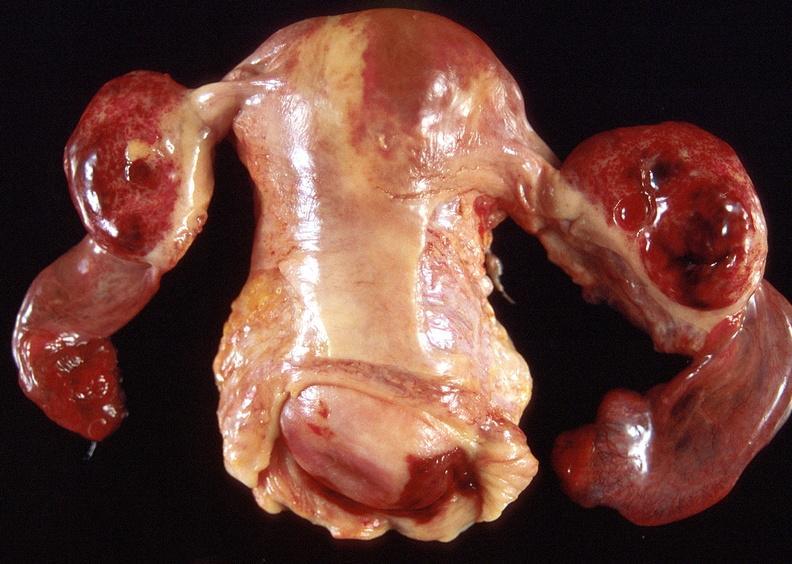does this image show ovarian cysts, hemorrhagic?
Answer the question using a single word or phrase. Yes 